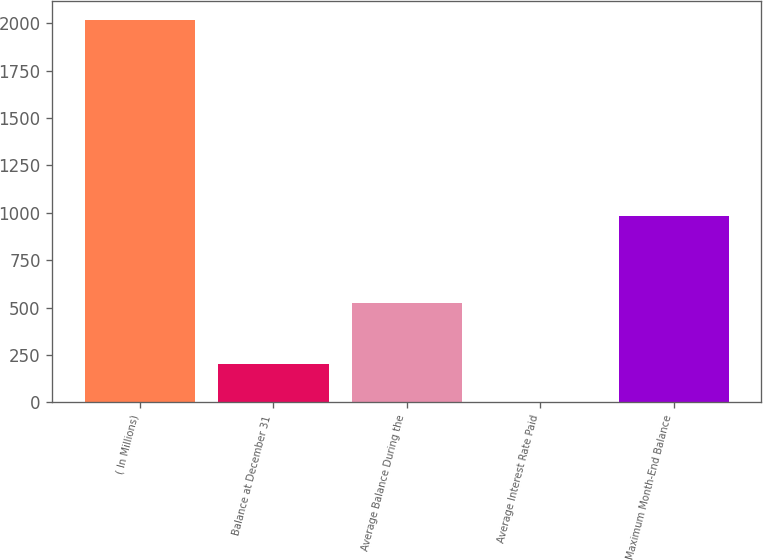<chart> <loc_0><loc_0><loc_500><loc_500><bar_chart><fcel>( In Millions)<fcel>Balance at December 31<fcel>Average Balance During the<fcel>Average Interest Rate Paid<fcel>Maximum Month-End Balance<nl><fcel>2018<fcel>203.13<fcel>525.2<fcel>1.48<fcel>981.3<nl></chart> 